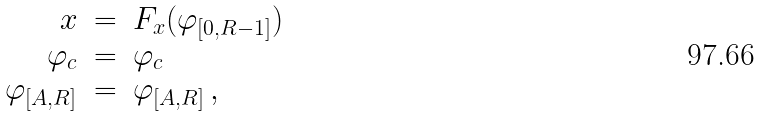Convert formula to latex. <formula><loc_0><loc_0><loc_500><loc_500>\begin{array} { r c l } x & = & F _ { x } ( \varphi _ { [ 0 , R - 1 ] } ) \\ \varphi _ { c } & = & \varphi _ { c } \\ \varphi _ { [ A , R ] } & = & \varphi _ { [ A , R ] } \, , \end{array}</formula> 